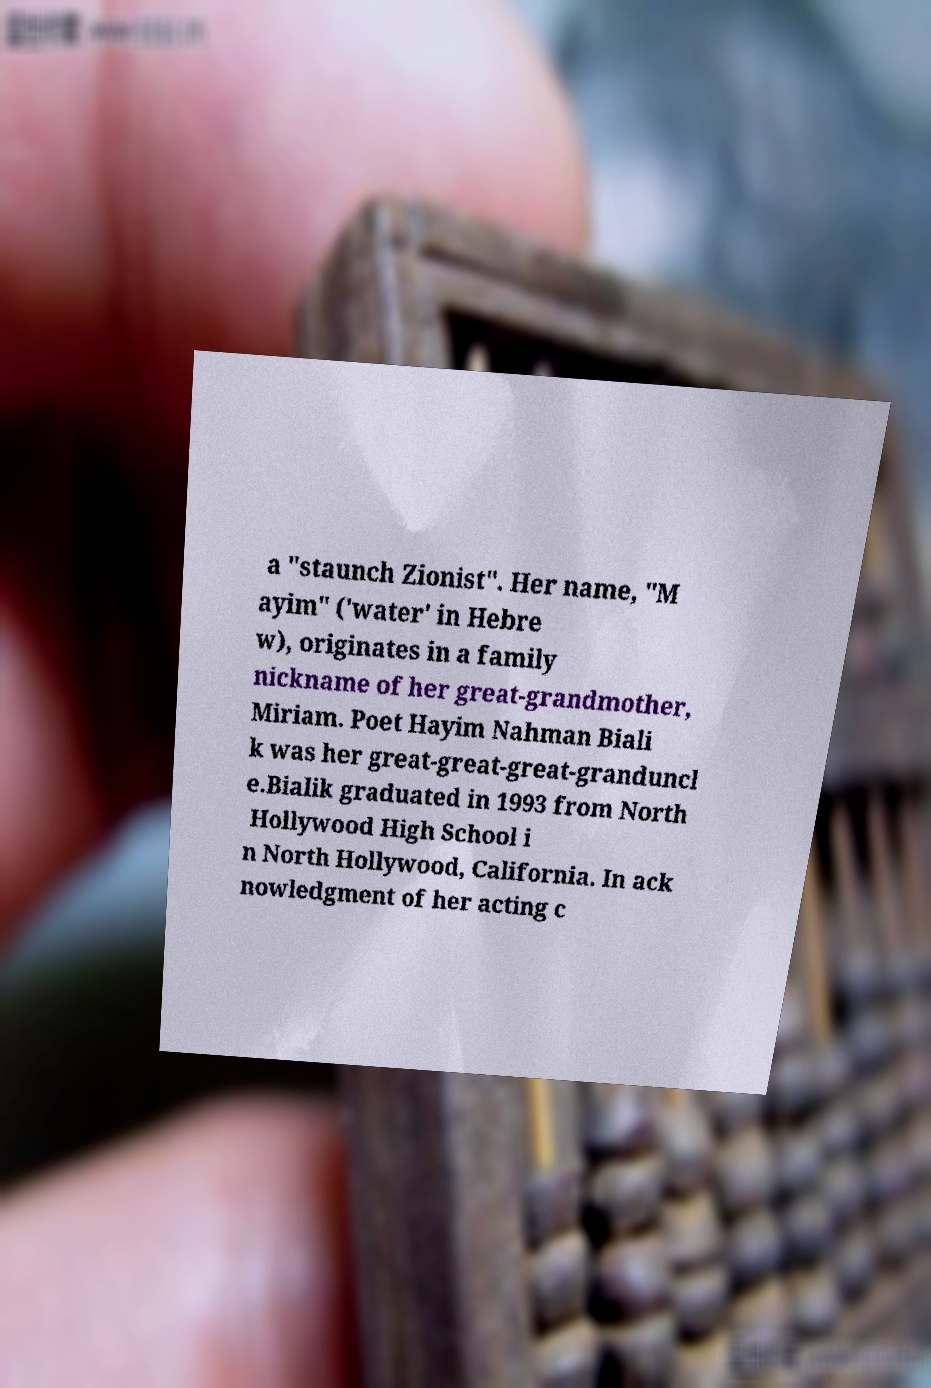Please identify and transcribe the text found in this image. a "staunch Zionist". Her name, "M ayim" ('water' in Hebre w), originates in a family nickname of her great-grandmother, Miriam. Poet Hayim Nahman Biali k was her great-great-great-granduncl e.Bialik graduated in 1993 from North Hollywood High School i n North Hollywood, California. In ack nowledgment of her acting c 